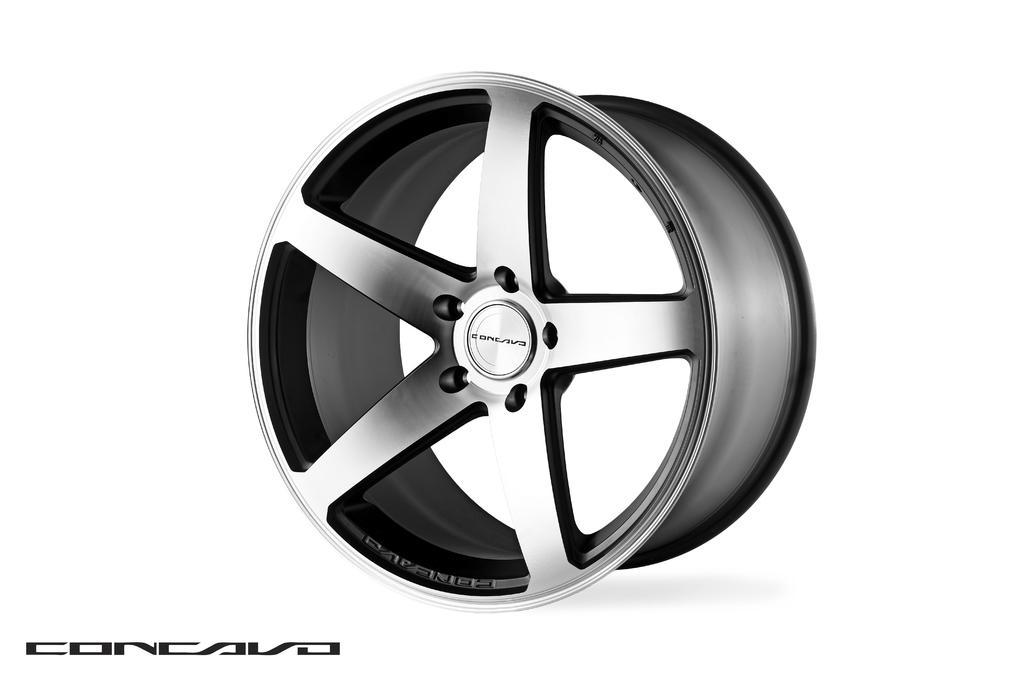How would you summarize this image in a sentence or two? This is an animated picture of an alloy wheel. 